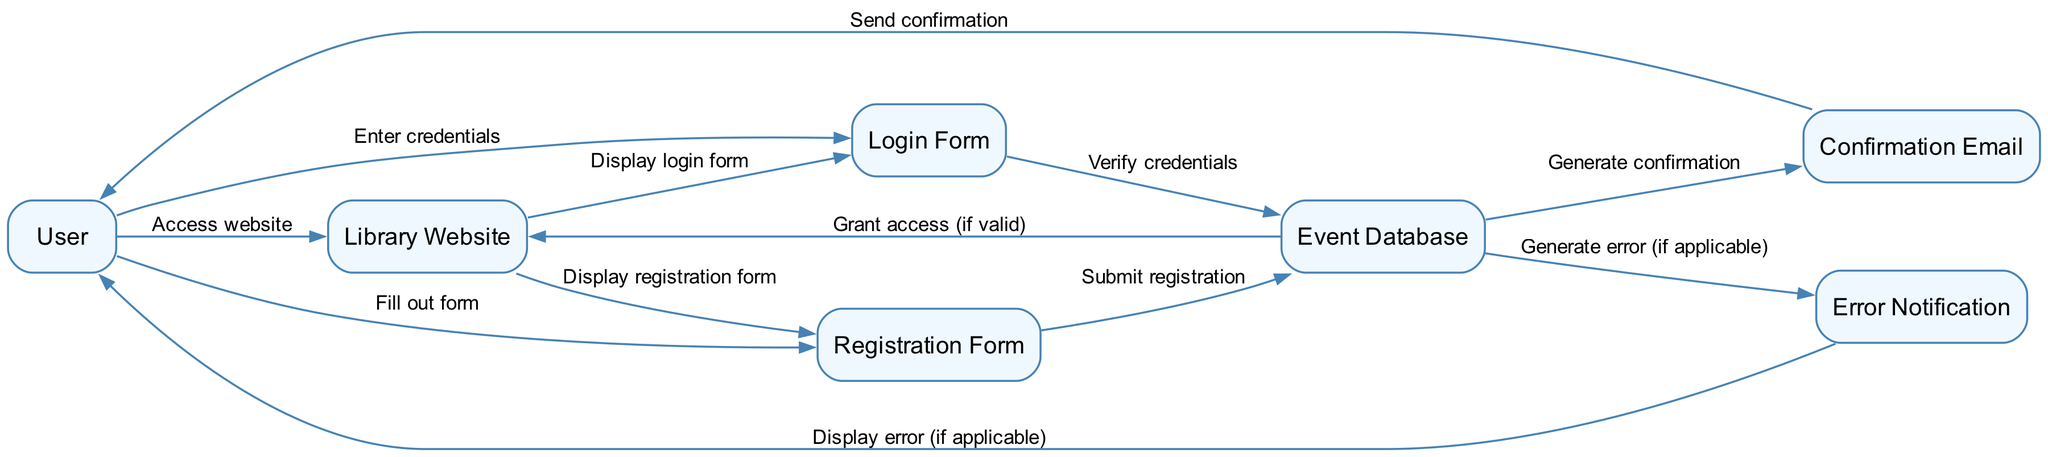What is the first action taken by the User? The first action taken by the User is to access the Library Website, as indicated by the edge that connects the User to the Library Website with the label 'Access website'.
Answer: Access website How many nodes are present in the diagram? The diagram consists of seven nodes: User, Library Website, Registration Form, Login Form, Event Database, Confirmation Email, and Error Notification. Counting each distinct element listed gives us the total of seven.
Answer: Seven What is displayed after the User fills out the Registration Form? After the User submits the Registration Form, the information is sent to the Event Database for processing, as shown by the edge labeled 'Submit registration' connecting the Registration Form to the Event Database.
Answer: Submit registration Which element generates a confirmation for the User? The Event Database is responsible for generating the confirmation email for the User after successful registration, as indicated by the edge labeled 'Generate confirmation' linking the Event Database to Confirmation Email.
Answer: Confirmation Email What happens if there is an error during registration? If an error occurs during registration, the Event Database generates an error notification, which then displays the error to the User. This is represented by the edge connecting both elements with the label 'Generate error (if applicable)'.
Answer: Error Notification What must the User enter in the Login Form? The User must enter credentials in the Login Form as indicated by the edge labeled 'Enter credentials' that connects the User to the Login Form.
Answer: Credentials How does the User know if their login attempt was successful? If the login attempt is successful, the Event Database grants access back to the Library Website, which signifies that the User is allowed to proceed. This flow is indicated by the labeled edge 'Grant access (if valid)' connecting Event Database to Library Website.
Answer: Grant access What is sent to the User upon successful registration? Upon successful registration, a Confirmation Email is sent to the User, as shown by the edge that leads from Event Database to Confirmation Email with the label 'Send confirmation'.
Answer: Confirmation Email 